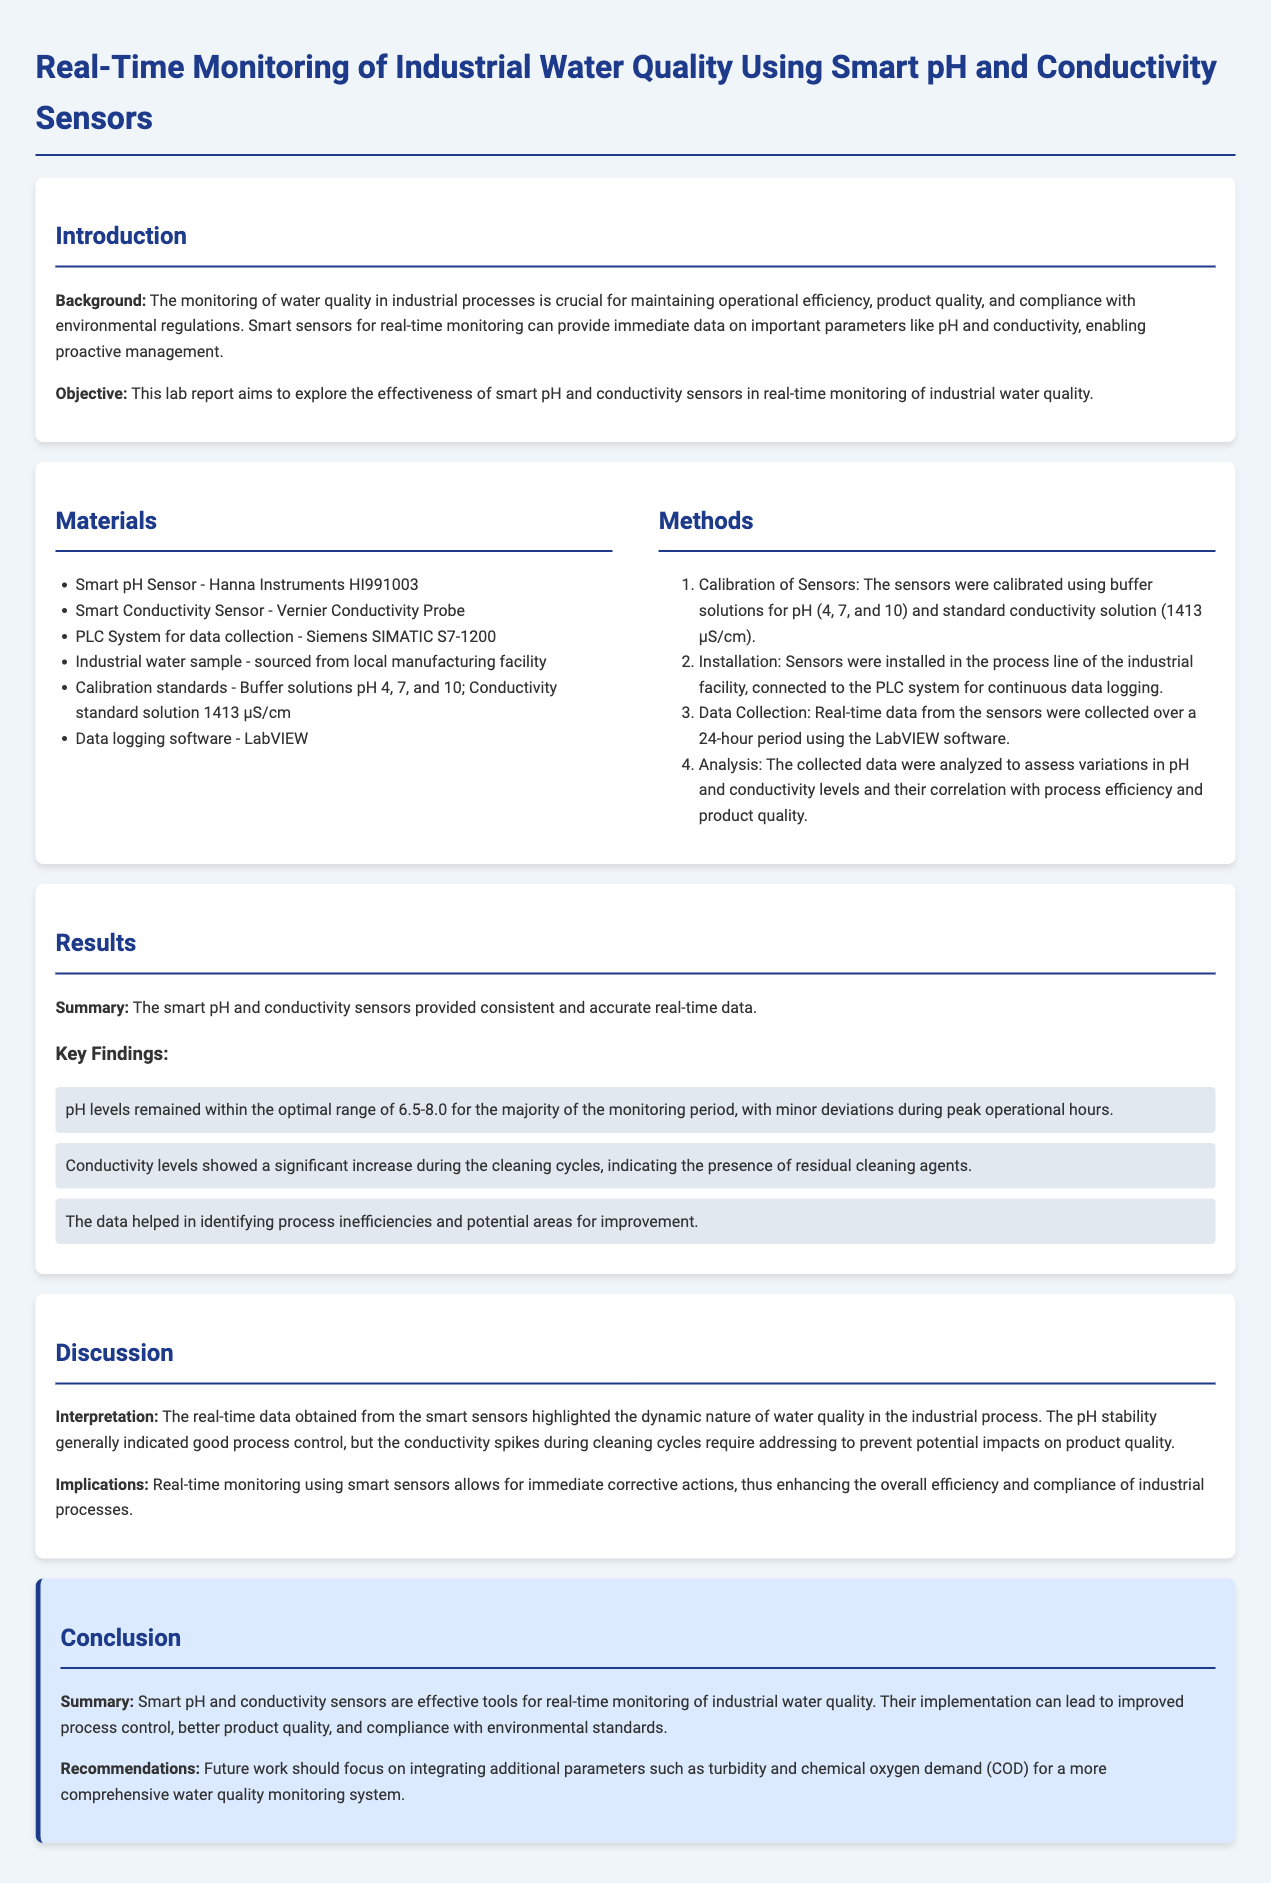What are the two types of sensors used? The introduction mentions the use of smart pH and conductivity sensors for monitoring water quality.
Answer: pH and conductivity sensors What is the calibration standard solution for conductivity? The materials section specifies the conductivity standard used during sensor calibration.
Answer: 1413 µS/cm What is the optimal pH range identified in the results? The results section indicates that pH levels remained within an optimal range.
Answer: 6.5-8.0 During what operational periods did minor pH deviations occur? The results highlight that deviations in pH levels were observed during specific operational times.
Answer: Peak operational hours What was the significant finding regarding conductivity levels? The results discuss an increase in conductivity during a specific time related to cleaning cycles.
Answer: Significant increase during cleaning cycles What is the primary objective of this lab report? The objective is clearly stated in the introduction, focusing on the effectiveness of the sensors.
Answer: Explore the effectiveness of smart sensors What software was used for data logging? The materials section lists the software used for collecting and analyzing the data.
Answer: LabVIEW What additional parameters are recommended for future work? The conclusion suggests integrating more parameters for a comprehensive monitoring system.
Answer: Turbidity and chemical oxygen demand (COD) 